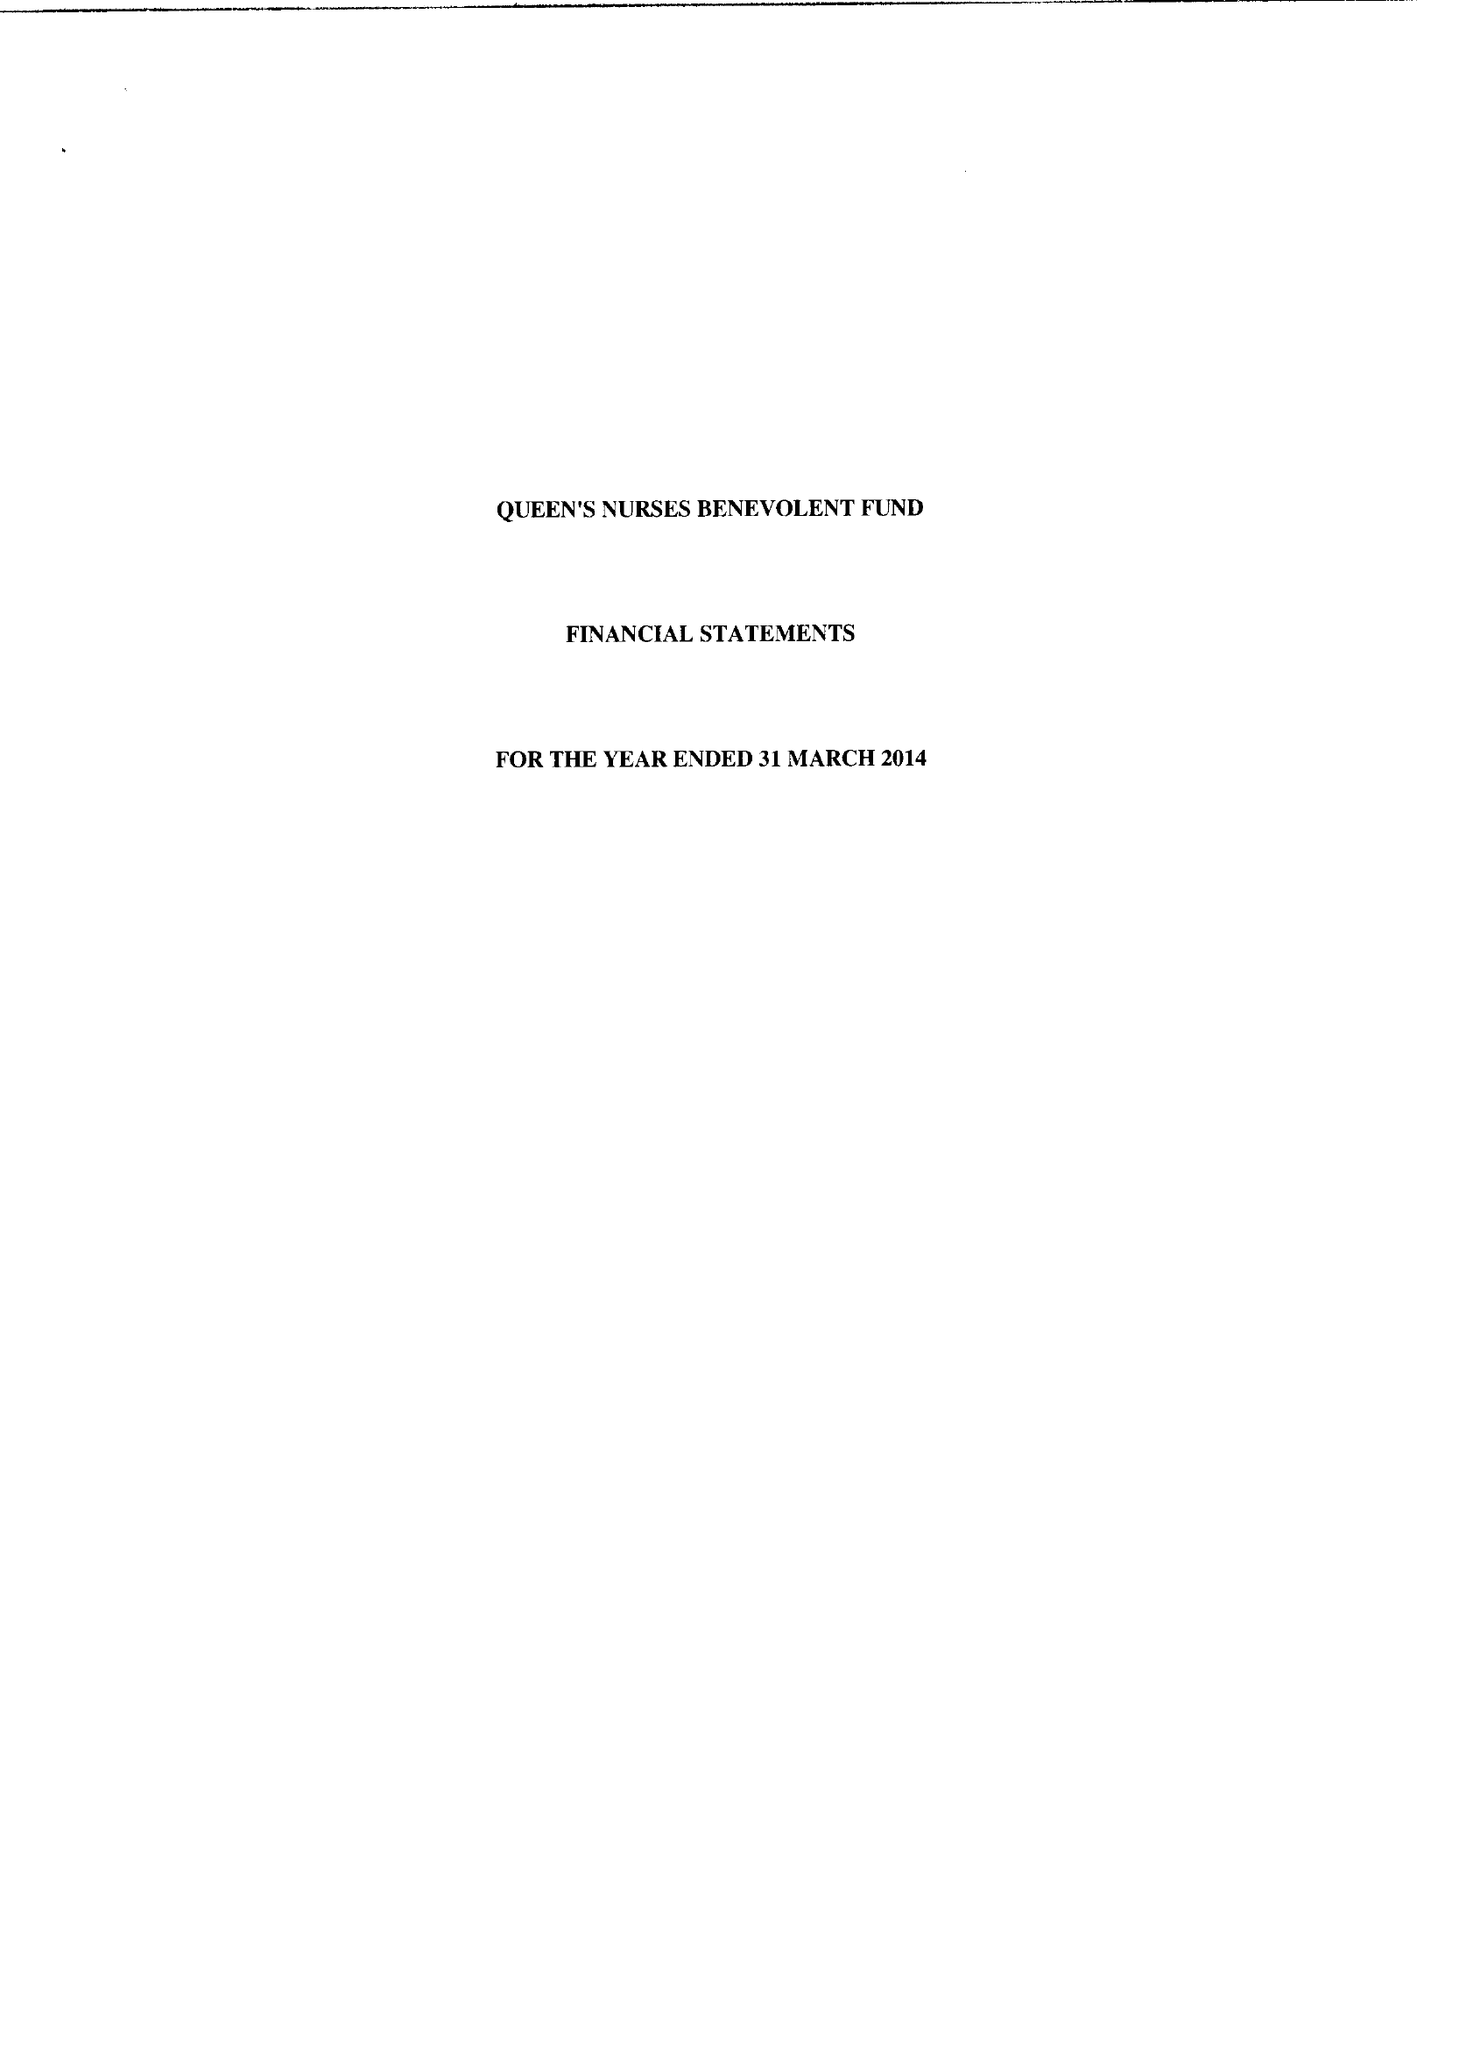What is the value for the charity_number?
Answer the question using a single word or phrase. 256462 